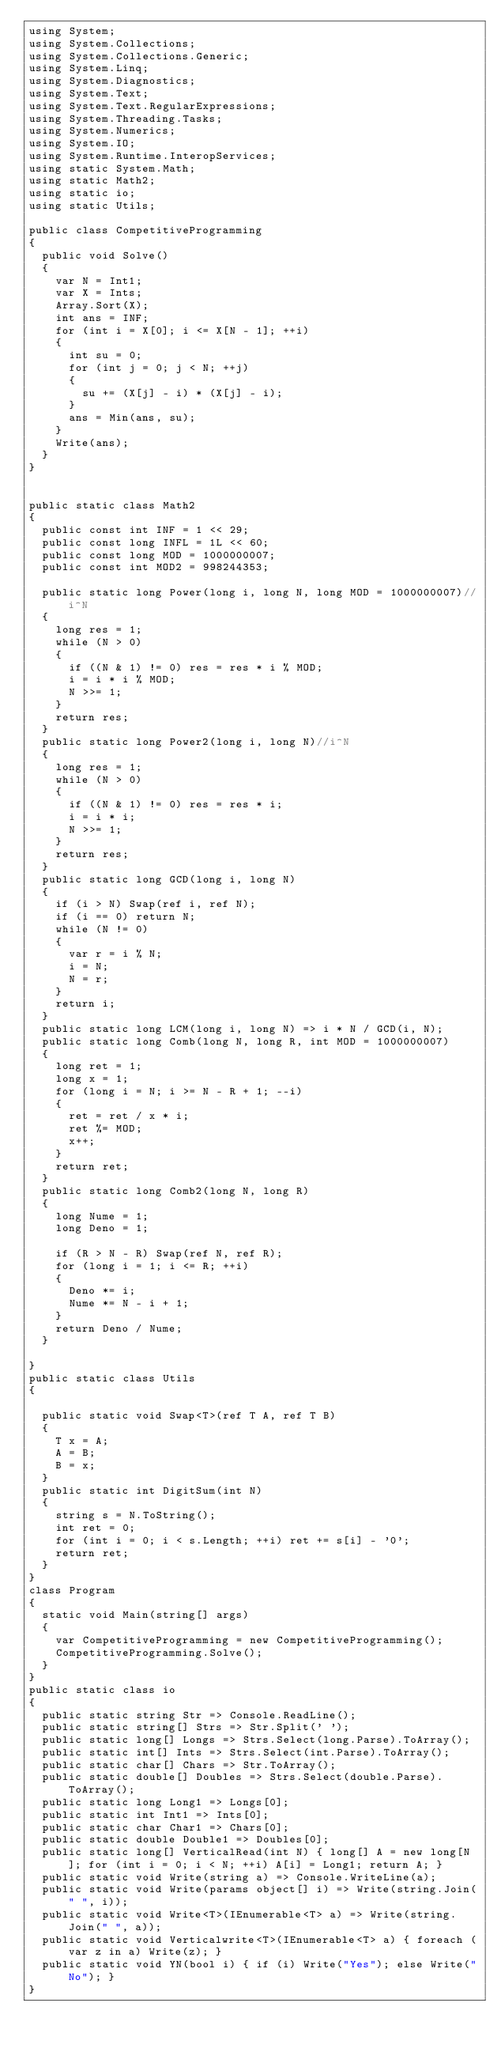<code> <loc_0><loc_0><loc_500><loc_500><_C#_>using System;
using System.Collections;
using System.Collections.Generic;
using System.Linq;
using System.Diagnostics;
using System.Text;
using System.Text.RegularExpressions;
using System.Threading.Tasks;
using System.Numerics;
using System.IO;
using System.Runtime.InteropServices;
using static System.Math;
using static Math2;
using static io;
using static Utils;

public class CompetitiveProgramming
{
  public void Solve()
  {
    var N = Int1;
    var X = Ints;
    Array.Sort(X);
    int ans = INF;
    for (int i = X[0]; i <= X[N - 1]; ++i)
    {
      int su = 0;
      for (int j = 0; j < N; ++j)
      {
        su += (X[j] - i) * (X[j] - i);
      }
      ans = Min(ans, su);
    }
    Write(ans);
  }
}


public static class Math2
{
  public const int INF = 1 << 29;
  public const long INFL = 1L << 60;
  public const long MOD = 1000000007;
  public const int MOD2 = 998244353;

  public static long Power(long i, long N, long MOD = 1000000007)//i^N
  {
    long res = 1;
    while (N > 0)
    {
      if ((N & 1) != 0) res = res * i % MOD;
      i = i * i % MOD;
      N >>= 1;
    }
    return res;
  }
  public static long Power2(long i, long N)//i^N
  {
    long res = 1;
    while (N > 0)
    {
      if ((N & 1) != 0) res = res * i;
      i = i * i;
      N >>= 1;
    }
    return res;
  }
  public static long GCD(long i, long N)
  {
    if (i > N) Swap(ref i, ref N);
    if (i == 0) return N;
    while (N != 0)
    {
      var r = i % N;
      i = N;
      N = r;
    }
    return i;
  }
  public static long LCM(long i, long N) => i * N / GCD(i, N);
  public static long Comb(long N, long R, int MOD = 1000000007)
  {
    long ret = 1;
    long x = 1;
    for (long i = N; i >= N - R + 1; --i)
    {
      ret = ret / x * i;
      ret %= MOD;
      x++;
    }
    return ret;
  }
  public static long Comb2(long N, long R)
  {
    long Nume = 1;
    long Deno = 1;

    if (R > N - R) Swap(ref N, ref R);
    for (long i = 1; i <= R; ++i)
    {
      Deno *= i;
      Nume *= N - i + 1;
    }
    return Deno / Nume;
  }

}
public static class Utils
{

  public static void Swap<T>(ref T A, ref T B)
  {
    T x = A;
    A = B;
    B = x;
  }
  public static int DigitSum(int N)
  {
    string s = N.ToString();
    int ret = 0;
    for (int i = 0; i < s.Length; ++i) ret += s[i] - '0';
    return ret;
  }
}
class Program
{
  static void Main(string[] args)
  {
    var CompetitiveProgramming = new CompetitiveProgramming();
    CompetitiveProgramming.Solve();
  }
}
public static class io
{
  public static string Str => Console.ReadLine();
  public static string[] Strs => Str.Split(' ');
  public static long[] Longs => Strs.Select(long.Parse).ToArray();
  public static int[] Ints => Strs.Select(int.Parse).ToArray();
  public static char[] Chars => Str.ToArray();
  public static double[] Doubles => Strs.Select(double.Parse).ToArray();
  public static long Long1 => Longs[0];
  public static int Int1 => Ints[0];
  public static char Char1 => Chars[0];
  public static double Double1 => Doubles[0];
  public static long[] VerticalRead(int N) { long[] A = new long[N]; for (int i = 0; i < N; ++i) A[i] = Long1; return A; }
  public static void Write(string a) => Console.WriteLine(a);
  public static void Write(params object[] i) => Write(string.Join(" ", i));
  public static void Write<T>(IEnumerable<T> a) => Write(string.Join(" ", a));
  public static void Verticalwrite<T>(IEnumerable<T> a) { foreach (var z in a) Write(z); }
  public static void YN(bool i) { if (i) Write("Yes"); else Write("No"); }
}
</code> 